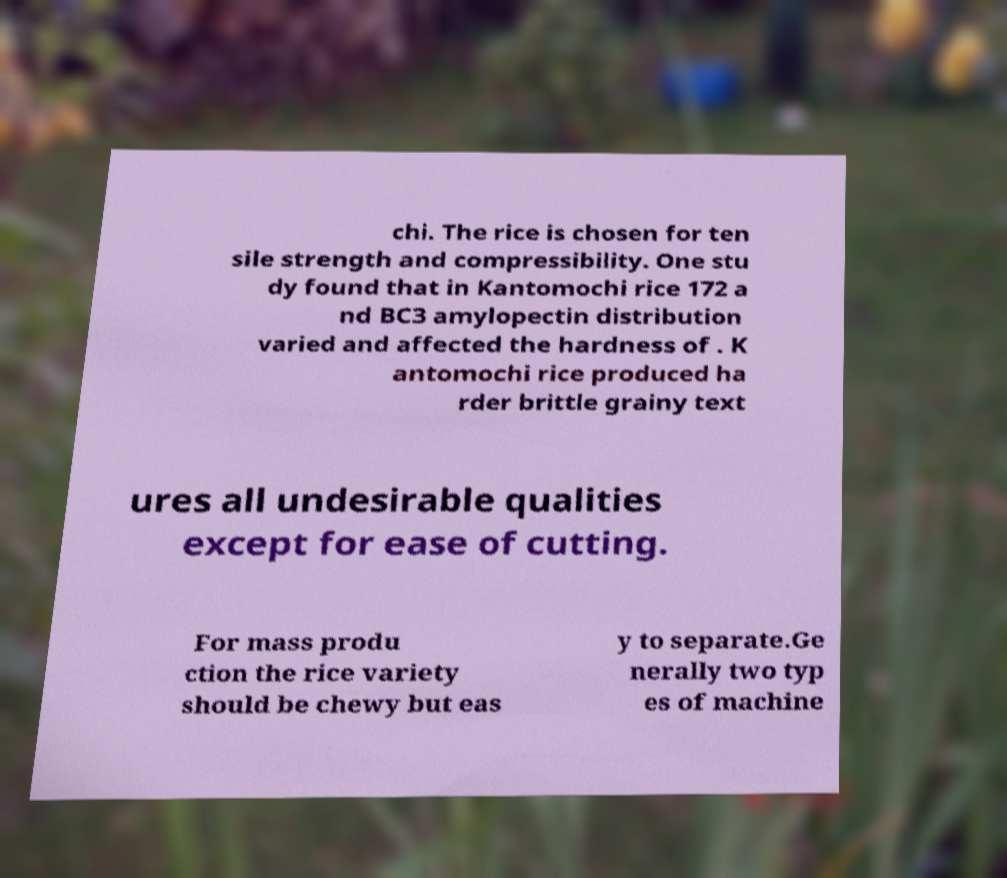Can you read and provide the text displayed in the image?This photo seems to have some interesting text. Can you extract and type it out for me? chi. The rice is chosen for ten sile strength and compressibility. One stu dy found that in Kantomochi rice 172 a nd BC3 amylopectin distribution varied and affected the hardness of . K antomochi rice produced ha rder brittle grainy text ures all undesirable qualities except for ease of cutting. For mass produ ction the rice variety should be chewy but eas y to separate.Ge nerally two typ es of machine 